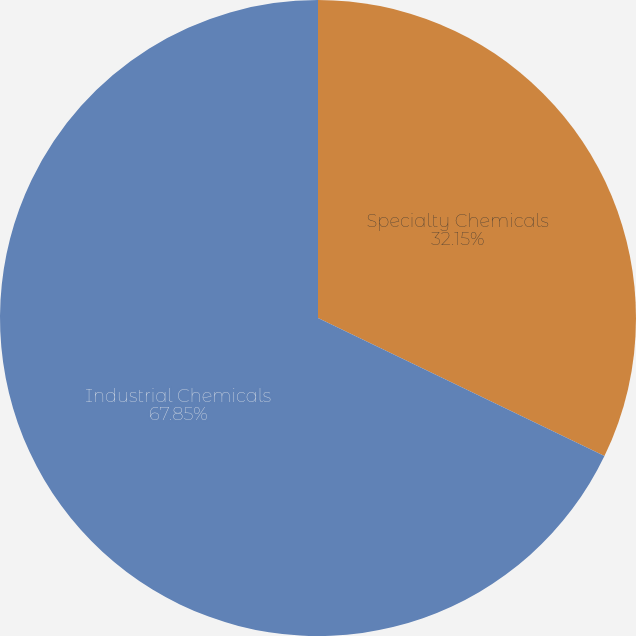Convert chart to OTSL. <chart><loc_0><loc_0><loc_500><loc_500><pie_chart><fcel>Specialty Chemicals<fcel>Industrial Chemicals<nl><fcel>32.15%<fcel>67.85%<nl></chart> 